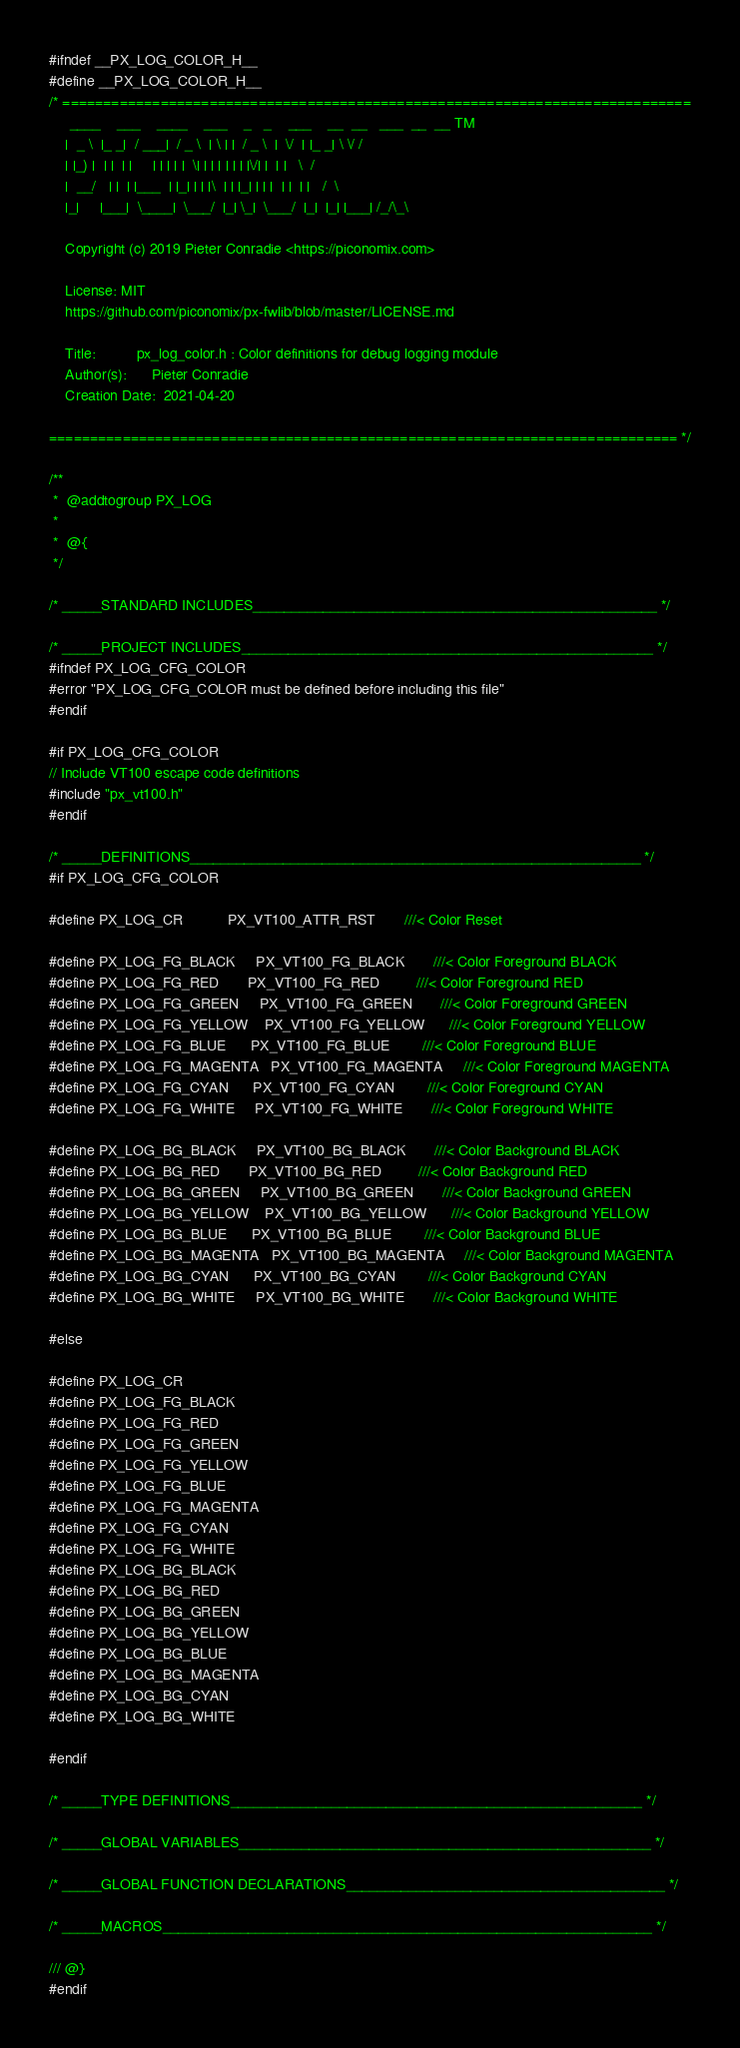<code> <loc_0><loc_0><loc_500><loc_500><_C_>#ifndef __PX_LOG_COLOR_H__
#define __PX_LOG_COLOR_H__
/* =============================================================================
     ____    ___    ____    ___    _   _    ___    __  __   ___  __  __ TM
    |  _ \  |_ _|  / ___|  / _ \  | \ | |  / _ \  |  \/  | |_ _| \ \/ /
    | |_) |  | |  | |     | | | | |  \| | | | | | | |\/| |  | |   \  /
    |  __/   | |  | |___  | |_| | | |\  | | |_| | | |  | |  | |   /  \
    |_|     |___|  \____|  \___/  |_| \_|  \___/  |_|  |_| |___| /_/\_\

    Copyright (c) 2019 Pieter Conradie <https://piconomix.com>
 
    License: MIT
    https://github.com/piconomix/px-fwlib/blob/master/LICENSE.md
 
    Title:          px_log_color.h : Color definitions for debug logging module
    Author(s):      Pieter Conradie
    Creation Date:  2021-04-20

============================================================================= */

/**
 *  @addtogroup PX_LOG
 *
 *  @{
 */

/* _____STANDARD INCLUDES____________________________________________________ */

/* _____PROJECT INCLUDES_____________________________________________________ */
#ifndef PX_LOG_CFG_COLOR
#error "PX_LOG_CFG_COLOR must be defined before including this file"
#endif

#if PX_LOG_CFG_COLOR
// Include VT100 escape code definitions
#include "px_vt100.h"
#endif

/* _____DEFINITIONS__________________________________________________________ */
#if PX_LOG_CFG_COLOR

#define PX_LOG_CR           PX_VT100_ATTR_RST       ///< Color Reset

#define PX_LOG_FG_BLACK     PX_VT100_FG_BLACK       ///< Color Foreground BLACK
#define PX_LOG_FG_RED       PX_VT100_FG_RED         ///< Color Foreground RED
#define PX_LOG_FG_GREEN     PX_VT100_FG_GREEN       ///< Color Foreground GREEN
#define PX_LOG_FG_YELLOW    PX_VT100_FG_YELLOW      ///< Color Foreground YELLOW
#define PX_LOG_FG_BLUE      PX_VT100_FG_BLUE        ///< Color Foreground BLUE
#define PX_LOG_FG_MAGENTA   PX_VT100_FG_MAGENTA     ///< Color Foreground MAGENTA
#define PX_LOG_FG_CYAN      PX_VT100_FG_CYAN        ///< Color Foreground CYAN
#define PX_LOG_FG_WHITE     PX_VT100_FG_WHITE       ///< Color Foreground WHITE

#define PX_LOG_BG_BLACK     PX_VT100_BG_BLACK       ///< Color Background BLACK
#define PX_LOG_BG_RED       PX_VT100_BG_RED         ///< Color Background RED
#define PX_LOG_BG_GREEN     PX_VT100_BG_GREEN       ///< Color Background GREEN
#define PX_LOG_BG_YELLOW    PX_VT100_BG_YELLOW      ///< Color Background YELLOW
#define PX_LOG_BG_BLUE      PX_VT100_BG_BLUE        ///< Color Background BLUE
#define PX_LOG_BG_MAGENTA   PX_VT100_BG_MAGENTA     ///< Color Background MAGENTA
#define PX_LOG_BG_CYAN      PX_VT100_BG_CYAN        ///< Color Background CYAN
#define PX_LOG_BG_WHITE     PX_VT100_BG_WHITE       ///< Color Background WHITE

#else

#define PX_LOG_CR
#define PX_LOG_FG_BLACK
#define PX_LOG_FG_RED
#define PX_LOG_FG_GREEN
#define PX_LOG_FG_YELLOW
#define PX_LOG_FG_BLUE
#define PX_LOG_FG_MAGENTA
#define PX_LOG_FG_CYAN
#define PX_LOG_FG_WHITE
#define PX_LOG_BG_BLACK
#define PX_LOG_BG_RED
#define PX_LOG_BG_GREEN
#define PX_LOG_BG_YELLOW
#define PX_LOG_BG_BLUE
#define PX_LOG_BG_MAGENTA
#define PX_LOG_BG_CYAN
#define PX_LOG_BG_WHITE

#endif

/* _____TYPE DEFINITIONS_____________________________________________________ */

/* _____GLOBAL VARIABLES_____________________________________________________ */

/* _____GLOBAL FUNCTION DECLARATIONS_________________________________________ */

/* _____MACROS_______________________________________________________________ */

/// @}
#endif
</code> 